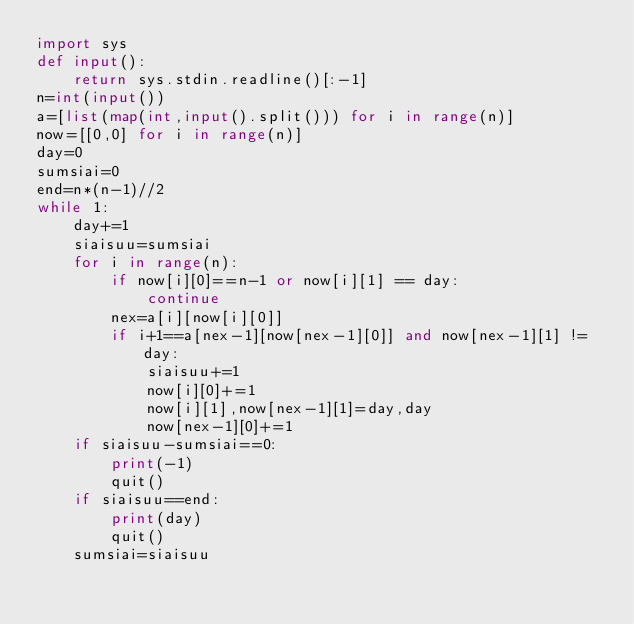Convert code to text. <code><loc_0><loc_0><loc_500><loc_500><_Python_>import sys
def input():
    return sys.stdin.readline()[:-1]
n=int(input())
a=[list(map(int,input().split())) for i in range(n)]
now=[[0,0] for i in range(n)]
day=0
sumsiai=0
end=n*(n-1)//2
while 1:
    day+=1
    siaisuu=sumsiai
    for i in range(n):
        if now[i][0]==n-1 or now[i][1] == day:
            continue
        nex=a[i][now[i][0]]
        if i+1==a[nex-1][now[nex-1][0]] and now[nex-1][1] != day:
            siaisuu+=1
            now[i][0]+=1
            now[i][1],now[nex-1][1]=day,day
            now[nex-1][0]+=1
    if siaisuu-sumsiai==0:
        print(-1)
        quit()
    if siaisuu==end:
        print(day)
        quit()
    sumsiai=siaisuu</code> 